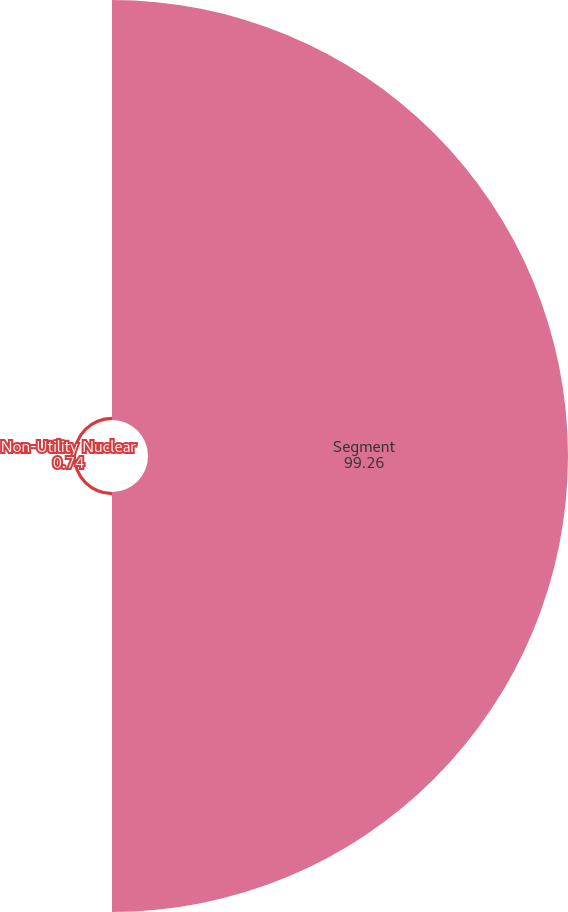<chart> <loc_0><loc_0><loc_500><loc_500><pie_chart><fcel>Segment<fcel>Non-Utility Nuclear<nl><fcel>99.26%<fcel>0.74%<nl></chart> 